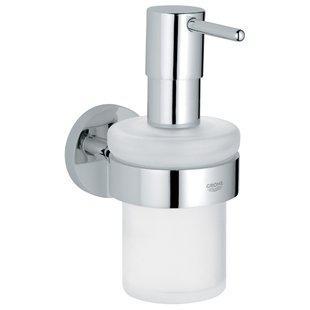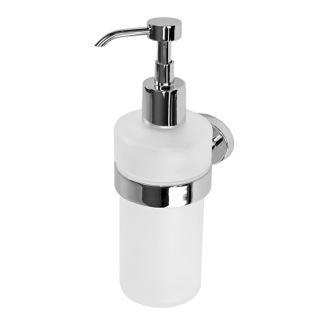The first image is the image on the left, the second image is the image on the right. Examine the images to the left and right. Is the description "There are two white plastic dispenser bottles." accurate? Answer yes or no. Yes. 